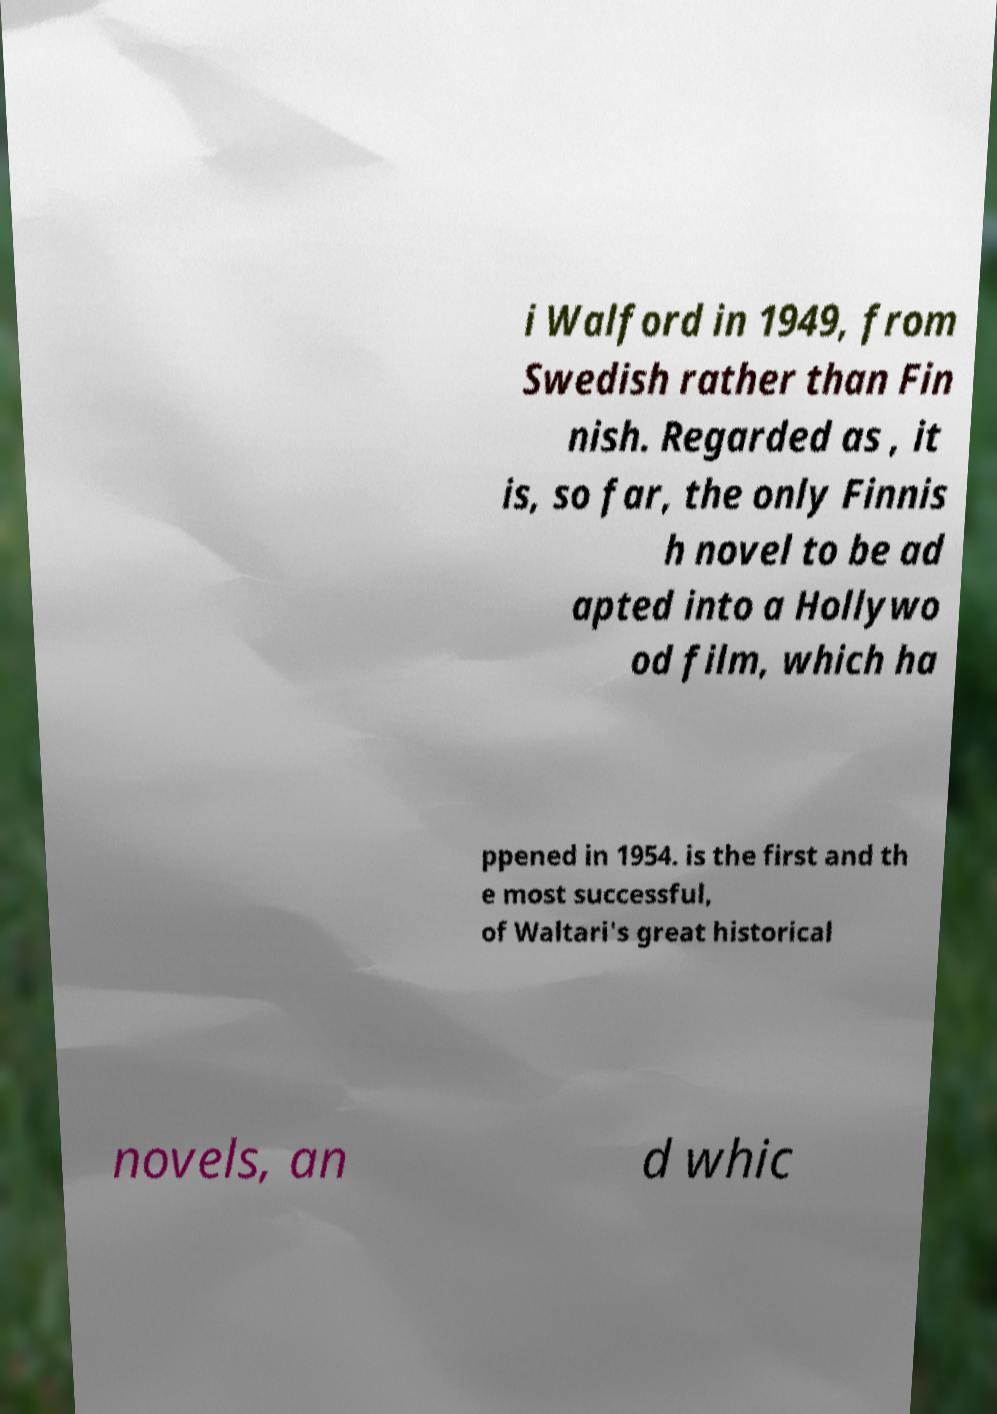There's text embedded in this image that I need extracted. Can you transcribe it verbatim? i Walford in 1949, from Swedish rather than Fin nish. Regarded as , it is, so far, the only Finnis h novel to be ad apted into a Hollywo od film, which ha ppened in 1954. is the first and th e most successful, of Waltari's great historical novels, an d whic 